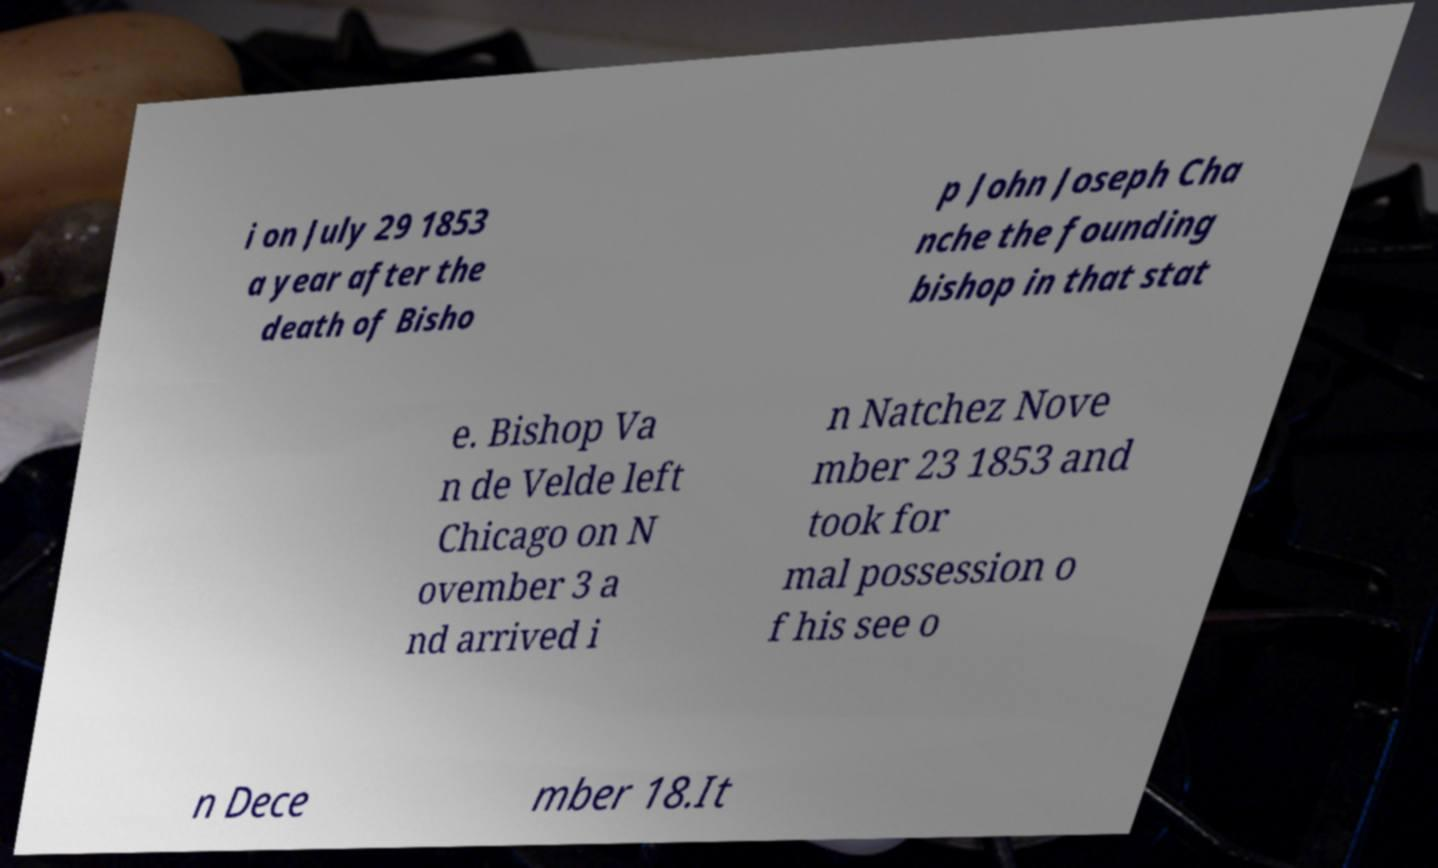Please read and relay the text visible in this image. What does it say? i on July 29 1853 a year after the death of Bisho p John Joseph Cha nche the founding bishop in that stat e. Bishop Va n de Velde left Chicago on N ovember 3 a nd arrived i n Natchez Nove mber 23 1853 and took for mal possession o f his see o n Dece mber 18.It 